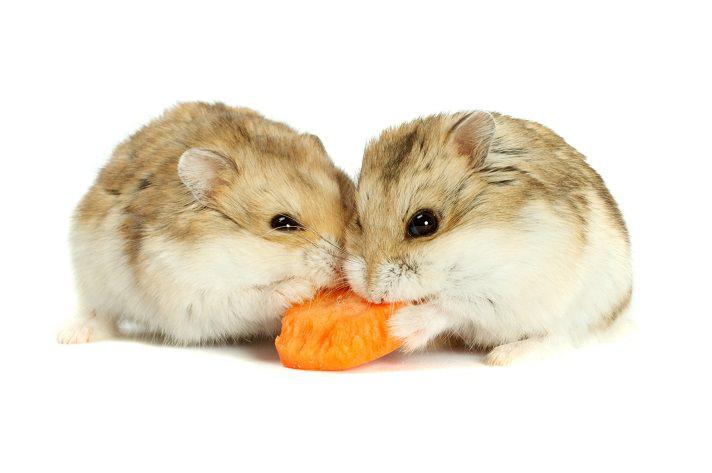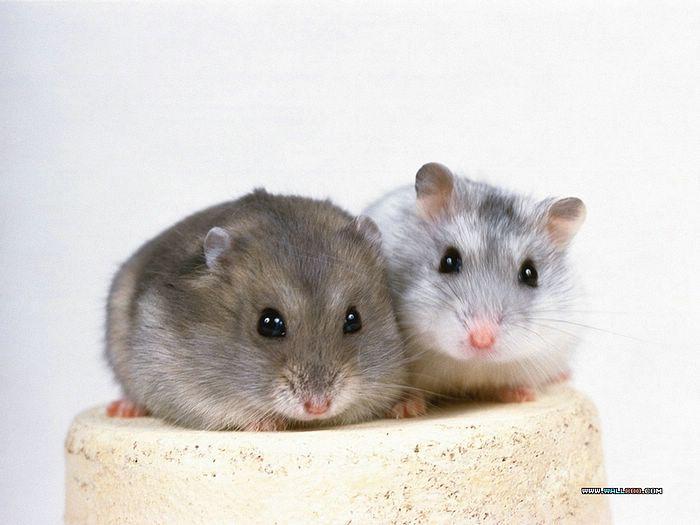The first image is the image on the left, the second image is the image on the right. Given the left and right images, does the statement "None of these rodents is snacking on a carrot slice." hold true? Answer yes or no. No. The first image is the image on the left, the second image is the image on the right. Assess this claim about the two images: "At least one hamster is eating a piece of carrot.". Correct or not? Answer yes or no. Yes. 